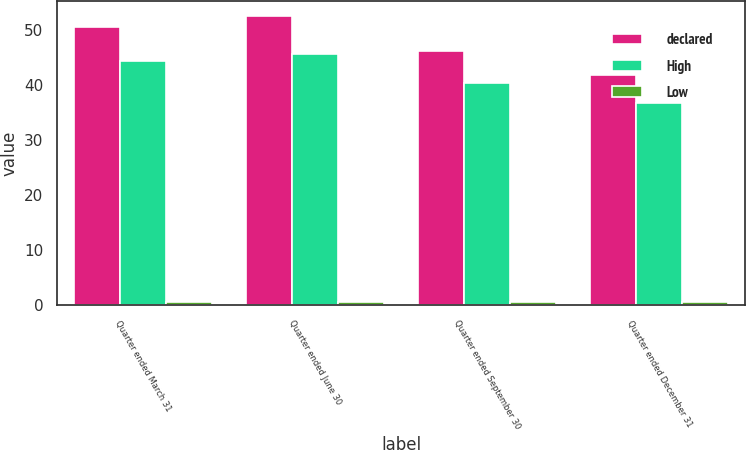Convert chart to OTSL. <chart><loc_0><loc_0><loc_500><loc_500><stacked_bar_chart><ecel><fcel>Quarter ended March 31<fcel>Quarter ended June 30<fcel>Quarter ended September 30<fcel>Quarter ended December 31<nl><fcel>declared<fcel>50.66<fcel>52.65<fcel>46.15<fcel>41.83<nl><fcel>High<fcel>44.44<fcel>45.66<fcel>40.48<fcel>36.72<nl><fcel>Low<fcel>0.7<fcel>0.7<fcel>0.7<fcel>0.7<nl></chart> 